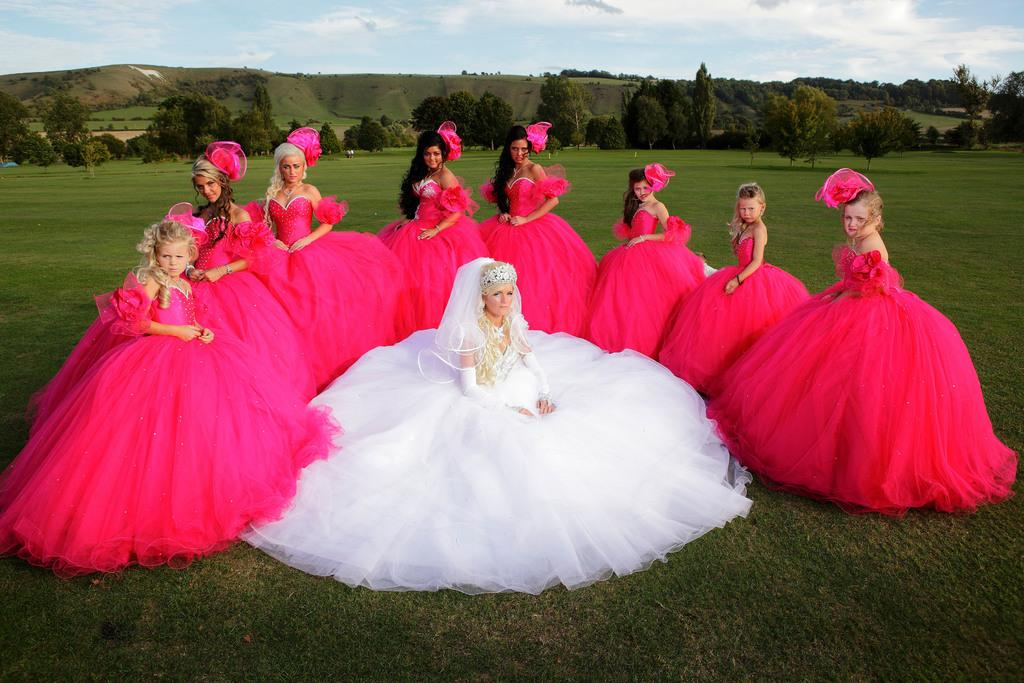How many people are in the image? There is a group of people in the image, but the exact number cannot be determined from the provided facts. What is the setting of the image? The people are standing on a grass field. What can be seen in the background of the image? There is a group of trees and hills visible in the background of the image. What is visible at the top of the image? The sky is visible at the top of the image. How long does it take for the minute to pass in the image? Time cannot be measured in an image, so it is not possible to determine how long a minute takes to pass. Is there a railway visible in the image? There is no mention of a railway in the provided facts, so it cannot be determined if one is present in the image. 